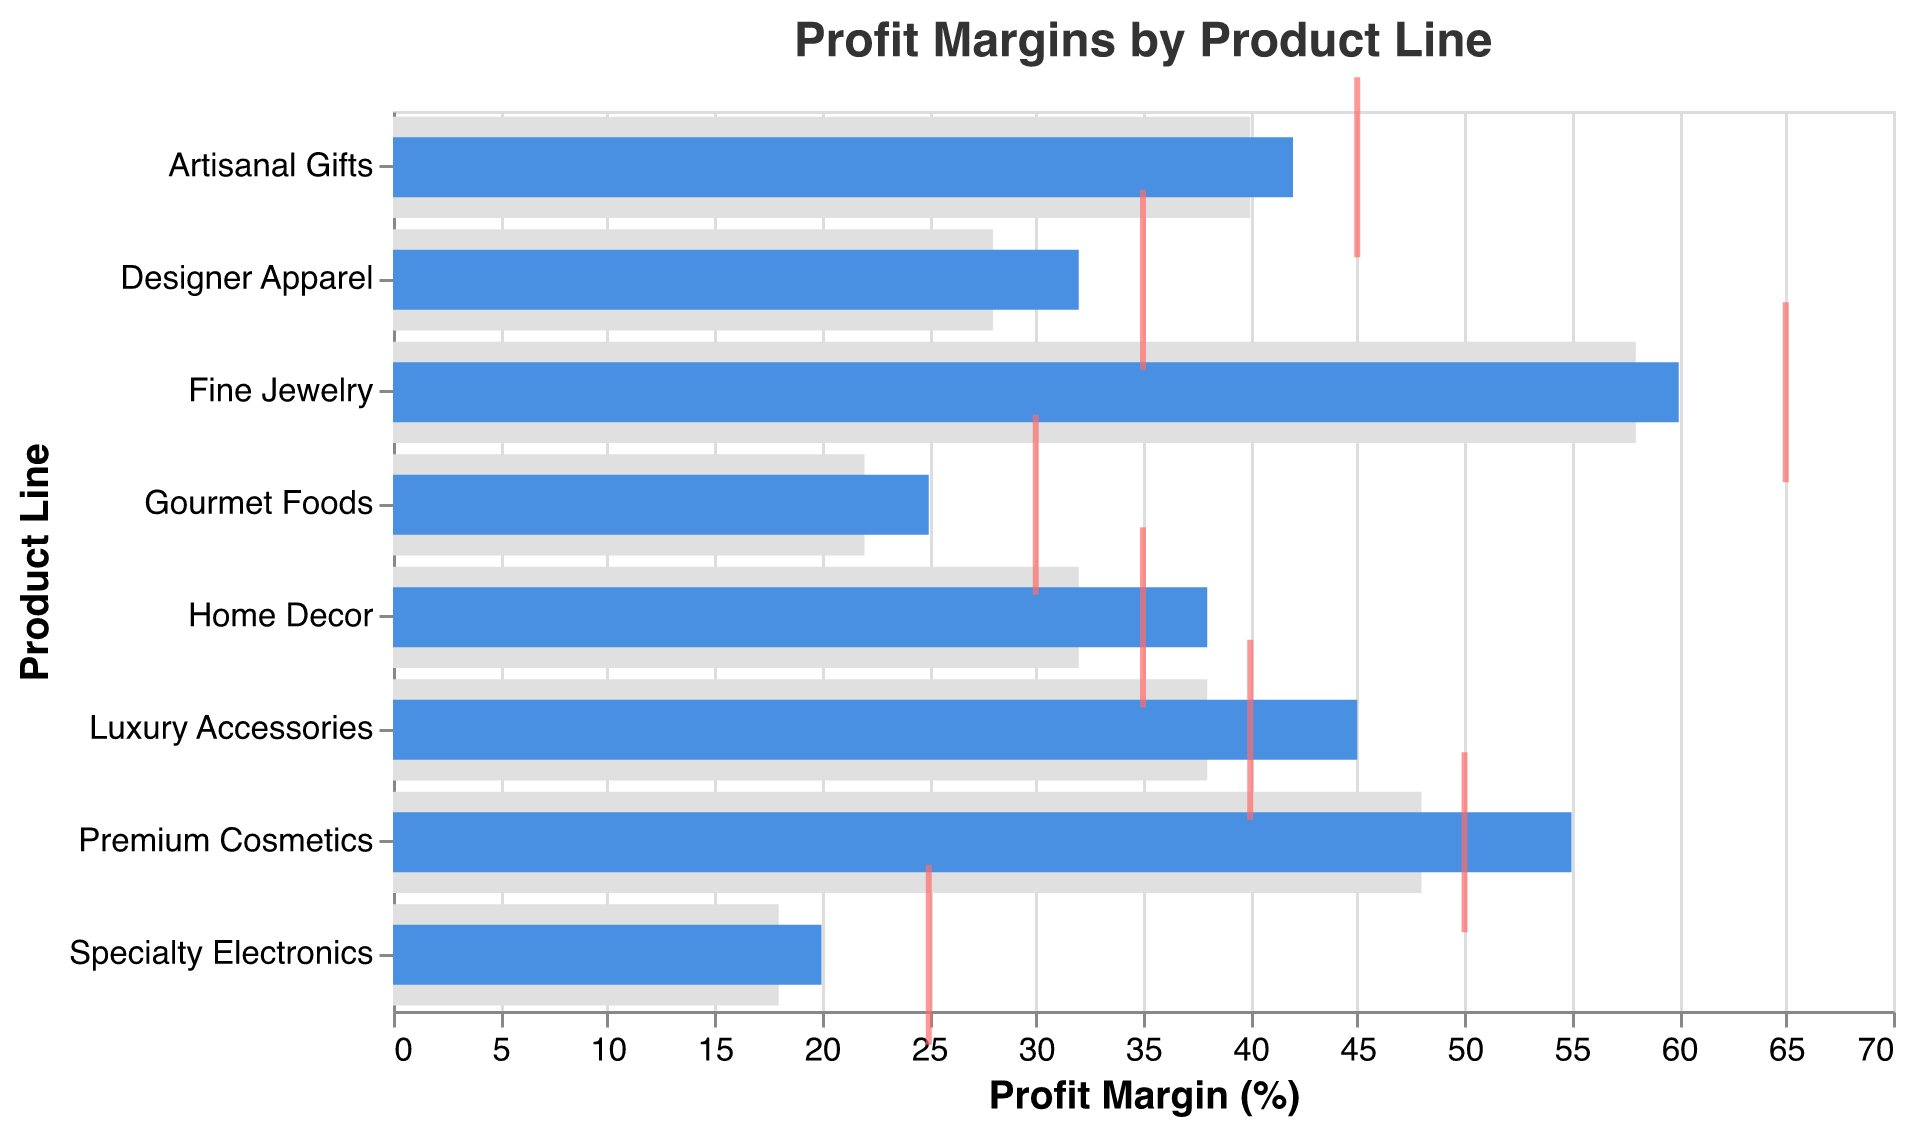What's the title of the chart? The title of the chart is displayed prominently at the top. It states, "Profit Margins by Product Line".
Answer: Profit Margins by Product Line What does the gray bar represent in the chart? The gray bar represents the "Competitor Average" profit margin percentage for each product line.
Answer: Competitor Average Which product line has the highest actual margin? By looking at the blue bars that represent actual margins, "Fine Jewelry" has the highest actual profit margin.
Answer: Fine Jewelry What is the target margin for Specialty Electronics, and how does it compare to its actual margin? The target margin for Specialty Electronics is indicated by the red tick mark and is 25%. The actual margin is shown by the blue bar and is 20%, which is 5% lower than the target.
Answer: Target: 25%, Actual: 20%, 5% lower Which product line achieved its target margin or exceeded it? By comparing the actual margin (blue bars) against the target margin (red ticks), "Luxury Accessories" and "Premium Cosmetics" meet or exceed their target margins.
Answer: Luxury Accessories, Premium Cosmetics What is the difference between the actual margin and the competitor average for Gourmet Foods? The actual margin for Gourmet Foods is 25% and the competitor average is 22%. The difference is calculated as 25% - 22% = 3%.
Answer: 3% How many product lines have an actual margin higher than the competitor average? By visually comparing the lengths of the blue bars (actual margins) to the gray bars (competitor averages), all product lines except Fine Jewelry and Specialty Electronics have higher actual margins than competitor averages.
Answer: 6 product lines Which product line has the smallest gap between its actual margin and the target margin? By closely looking at the distance between the blue bars (actual margins) and the red ticks (target margins), "Premium Cosmetics" has the smallest gap of 5%.
Answer: Premium Cosmetics What are the actual margin values for all product lines? Reading off the length of the blue bars for each product line, the actual margins are: Designer Apparel: 32%, Luxury Accessories: 45%, Premium Cosmetics: 55%, Fine Jewelry: 60%, Gourmet Foods: 25%, Home Decor: 38%, Artisanal Gifts: 42%, Specialty Electronics: 20%.
Answer: 32%, 45%, 55%, 60%, 25%, 38%, 42%, 20% 